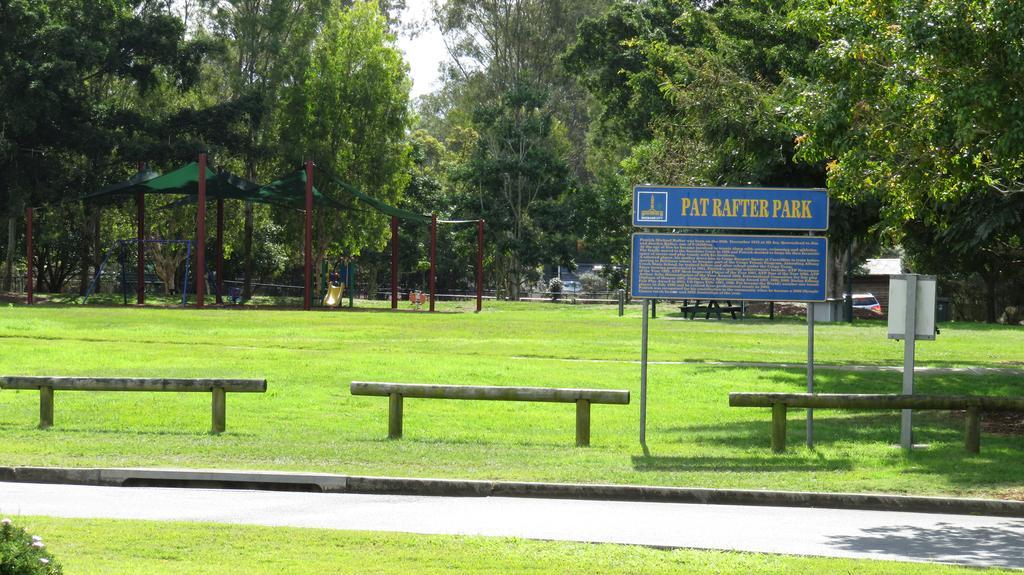In one or two sentences, can you explain what this image depicts? In this image I can see on the left side it looks like a tent, under that there is a slider. At the back side there are trees, on the right side there is the board. At the top it is the sky. 